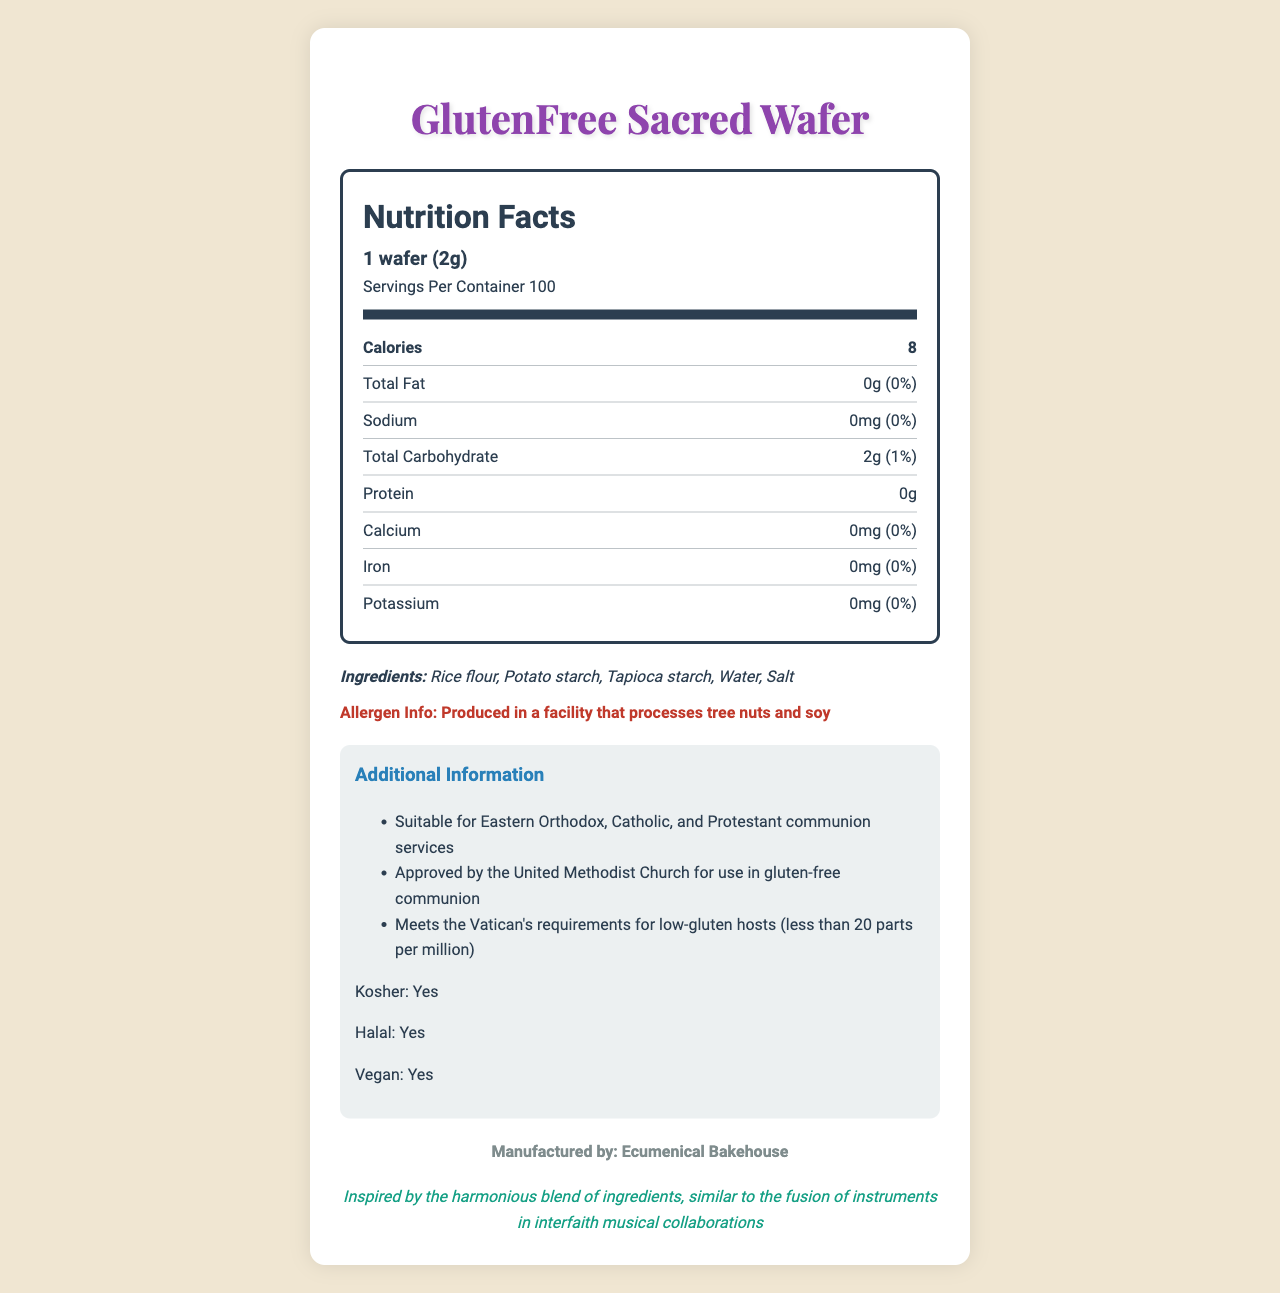what is the serving size for the GlutenFree Sacred Wafer? The serving size is mentioned at the top of the Nutrition Facts section.
Answer: 1 wafer (2g) how many servings are in the container? The number of servings per container is provided in the Nutrition Facts section.
Answer: 100 how many calories are in one serving of the wafer? The number of calories per serving is listed under the Calories section of the Nutrition Facts.
Answer: 8 what is the amount of total carbohydrates in one wafer? The total carbohydrate amount is given in the Nutrition Facts section under Total Carbohydrate.
Answer: 2g what ingredients are used to make the GlutenFree Sacred Wafer? The ingredients are listed in the Ingredients section.
Answer: Rice flour, Potato starch, Tapioca starch, Water, Salt is the GlutenFree Sacred Wafer produced in a facility that processes allergens? The allergen information clearly states that it is produced in a facility that processes tree nuts and soy.
Answer: Yes which religious groups approve the GlutenFree Sacred Wafer for communion services? A. Jewish B. Catholic C. Hindu D. Protestant The additional information indicates that the wafer is suitable for Catholic and Protestant communion services, but does not mention Jewish or Hindu.
Answer: B, D what is the daily value percentage of calcium in the wafer? The daily value percentage of calcium is specified as 0% in the Nutrition Facts.
Answer: 0% is the GlutenFree Sacred Wafer appropriate for vegans? The document mentions that the product is vegan.
Answer: Yes does the GlutenFree Sacred Wafer meet the Vatican's requirements for low-gluten hosts? The additional information confirms that it meets the Vatican's requirements for low-gluten hosts.
Answer: Yes summarize the main idea of the document. The concise main idea covers the product attributes, nutritional information, religious approvals, manufacturer, and the unique inspiration behind the product.
Answer: The GlutenFree Sacred Wafer is a communion wafer that is gluten-free, vegan, kosher, and halal. It contains minimal nutritional content focusing on low-calorie and low-carbohydrate values. The wafer is made from rice flour, potato starch, tapioca starch, water, and salt, and is produced in a facility that processes tree nuts and soy. It's suitable for various Christian denominations and meets certain religious standards. Manufactured by Ecumenical Bakehouse, the product is inspired by the harmonious blend of ingredients akin to interfaith musical collaborations. what is the amount of protein in one wafer? The protein content is listed as 0g in the Nutrition Facts section.
Answer: 0g does the GlutenFree Sacred Wafer contain any iron? The Nutrition Facts section shows that iron content is 0mg, indicating it does not contain any iron.
Answer: No where is the GlutenFree Sacred Wafer manufactured? The manufacturing details are provided at the end of the document.
Answer: Ecumenical Bakehouse does the document specify a price for the GlutenFree Sacred Wafer? There is no pricing information in the provided document.
Answer: Not enough information 